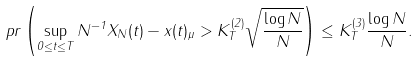Convert formula to latex. <formula><loc_0><loc_0><loc_500><loc_500>\ p r \left ( \sup _ { 0 \leq t \leq T } \| N ^ { - 1 } X _ { N } ( t ) - x ( t ) \| _ { \mu } > K _ { T } ^ { ( 2 ) } \sqrt { \frac { \log N } { N } } \right ) \leq K ^ { ( 3 ) } _ { T } \frac { \log N } { N } .</formula> 